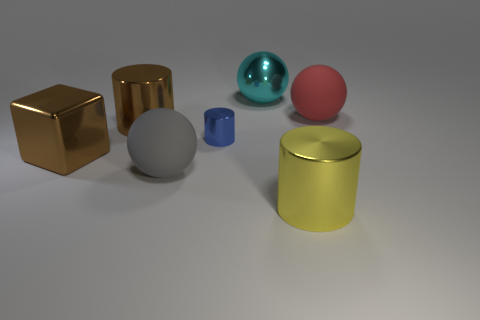How many other objects are the same color as the block?
Ensure brevity in your answer.  1. Do the metallic object that is in front of the big gray sphere and the blue thing have the same shape?
Ensure brevity in your answer.  Yes. Are there fewer big matte objects right of the small cylinder than rubber balls?
Provide a succinct answer. Yes. Are there any gray objects made of the same material as the tiny blue thing?
Make the answer very short. No. What material is the yellow cylinder that is the same size as the red matte ball?
Your answer should be very brief. Metal. Is the number of blue objects right of the tiny blue cylinder less than the number of large shiny cylinders that are behind the metallic cube?
Provide a short and direct response. Yes. The metallic object that is to the left of the small cylinder and in front of the small shiny cylinder has what shape?
Your response must be concise. Cube. What number of large cyan things are the same shape as the red thing?
Your answer should be very brief. 1. What size is the brown cylinder that is made of the same material as the large cyan sphere?
Your answer should be very brief. Large. Are there more large gray things than tiny gray matte balls?
Offer a terse response. Yes. 